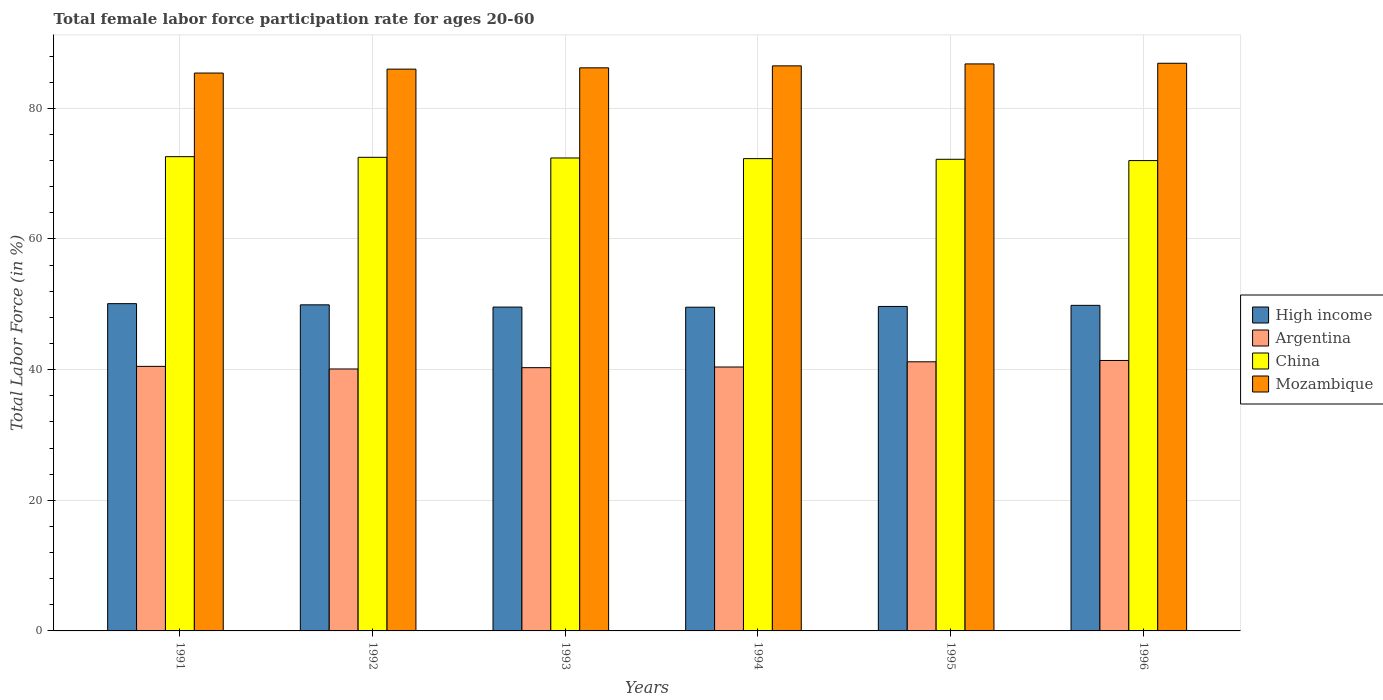How many different coloured bars are there?
Your response must be concise. 4. How many groups of bars are there?
Your answer should be compact. 6. Are the number of bars per tick equal to the number of legend labels?
Make the answer very short. Yes. How many bars are there on the 6th tick from the left?
Your answer should be compact. 4. How many bars are there on the 3rd tick from the right?
Your answer should be compact. 4. What is the female labor force participation rate in Argentina in 1996?
Offer a very short reply. 41.4. Across all years, what is the maximum female labor force participation rate in High income?
Give a very brief answer. 50.1. Across all years, what is the minimum female labor force participation rate in Mozambique?
Your answer should be very brief. 85.4. What is the total female labor force participation rate in China in the graph?
Provide a succinct answer. 434. What is the difference between the female labor force participation rate in Argentina in 1991 and that in 1994?
Provide a succinct answer. 0.1. What is the difference between the female labor force participation rate in Mozambique in 1991 and the female labor force participation rate in Argentina in 1994?
Your answer should be very brief. 45. What is the average female labor force participation rate in High income per year?
Your answer should be very brief. 49.78. In the year 1995, what is the difference between the female labor force participation rate in High income and female labor force participation rate in Argentina?
Give a very brief answer. 8.47. What is the ratio of the female labor force participation rate in High income in 1992 to that in 1993?
Keep it short and to the point. 1.01. Is the female labor force participation rate in High income in 1992 less than that in 1993?
Your response must be concise. No. What is the difference between the highest and the second highest female labor force participation rate in Mozambique?
Ensure brevity in your answer.  0.1. What is the difference between the highest and the lowest female labor force participation rate in High income?
Your answer should be compact. 0.54. What does the 4th bar from the left in 1991 represents?
Give a very brief answer. Mozambique. What does the 3rd bar from the right in 1993 represents?
Provide a succinct answer. Argentina. Is it the case that in every year, the sum of the female labor force participation rate in High income and female labor force participation rate in China is greater than the female labor force participation rate in Argentina?
Make the answer very short. Yes. How many years are there in the graph?
Give a very brief answer. 6. What is the difference between two consecutive major ticks on the Y-axis?
Provide a short and direct response. 20. Are the values on the major ticks of Y-axis written in scientific E-notation?
Keep it short and to the point. No. Does the graph contain any zero values?
Give a very brief answer. No. Does the graph contain grids?
Offer a very short reply. Yes. Where does the legend appear in the graph?
Provide a succinct answer. Center right. How many legend labels are there?
Make the answer very short. 4. How are the legend labels stacked?
Offer a terse response. Vertical. What is the title of the graph?
Offer a terse response. Total female labor force participation rate for ages 20-60. What is the label or title of the X-axis?
Your answer should be compact. Years. What is the Total Labor Force (in %) of High income in 1991?
Your response must be concise. 50.1. What is the Total Labor Force (in %) in Argentina in 1991?
Your answer should be compact. 40.5. What is the Total Labor Force (in %) in China in 1991?
Make the answer very short. 72.6. What is the Total Labor Force (in %) in Mozambique in 1991?
Keep it short and to the point. 85.4. What is the Total Labor Force (in %) in High income in 1992?
Your answer should be very brief. 49.92. What is the Total Labor Force (in %) of Argentina in 1992?
Provide a short and direct response. 40.1. What is the Total Labor Force (in %) in China in 1992?
Your answer should be compact. 72.5. What is the Total Labor Force (in %) in Mozambique in 1992?
Your answer should be very brief. 86. What is the Total Labor Force (in %) of High income in 1993?
Provide a short and direct response. 49.58. What is the Total Labor Force (in %) in Argentina in 1993?
Your answer should be very brief. 40.3. What is the Total Labor Force (in %) of China in 1993?
Provide a short and direct response. 72.4. What is the Total Labor Force (in %) of Mozambique in 1993?
Ensure brevity in your answer.  86.2. What is the Total Labor Force (in %) of High income in 1994?
Give a very brief answer. 49.56. What is the Total Labor Force (in %) of Argentina in 1994?
Keep it short and to the point. 40.4. What is the Total Labor Force (in %) of China in 1994?
Your answer should be compact. 72.3. What is the Total Labor Force (in %) in Mozambique in 1994?
Give a very brief answer. 86.5. What is the Total Labor Force (in %) in High income in 1995?
Your response must be concise. 49.67. What is the Total Labor Force (in %) in Argentina in 1995?
Keep it short and to the point. 41.2. What is the Total Labor Force (in %) in China in 1995?
Offer a terse response. 72.2. What is the Total Labor Force (in %) of Mozambique in 1995?
Make the answer very short. 86.8. What is the Total Labor Force (in %) of High income in 1996?
Ensure brevity in your answer.  49.84. What is the Total Labor Force (in %) of Argentina in 1996?
Keep it short and to the point. 41.4. What is the Total Labor Force (in %) in Mozambique in 1996?
Offer a terse response. 86.9. Across all years, what is the maximum Total Labor Force (in %) in High income?
Your answer should be very brief. 50.1. Across all years, what is the maximum Total Labor Force (in %) in Argentina?
Make the answer very short. 41.4. Across all years, what is the maximum Total Labor Force (in %) of China?
Ensure brevity in your answer.  72.6. Across all years, what is the maximum Total Labor Force (in %) in Mozambique?
Ensure brevity in your answer.  86.9. Across all years, what is the minimum Total Labor Force (in %) of High income?
Keep it short and to the point. 49.56. Across all years, what is the minimum Total Labor Force (in %) in Argentina?
Ensure brevity in your answer.  40.1. Across all years, what is the minimum Total Labor Force (in %) of Mozambique?
Provide a succinct answer. 85.4. What is the total Total Labor Force (in %) in High income in the graph?
Give a very brief answer. 298.66. What is the total Total Labor Force (in %) of Argentina in the graph?
Give a very brief answer. 243.9. What is the total Total Labor Force (in %) of China in the graph?
Offer a very short reply. 434. What is the total Total Labor Force (in %) of Mozambique in the graph?
Offer a terse response. 517.8. What is the difference between the Total Labor Force (in %) of High income in 1991 and that in 1992?
Give a very brief answer. 0.18. What is the difference between the Total Labor Force (in %) of China in 1991 and that in 1992?
Ensure brevity in your answer.  0.1. What is the difference between the Total Labor Force (in %) of Mozambique in 1991 and that in 1992?
Make the answer very short. -0.6. What is the difference between the Total Labor Force (in %) of High income in 1991 and that in 1993?
Your answer should be compact. 0.52. What is the difference between the Total Labor Force (in %) of Argentina in 1991 and that in 1993?
Ensure brevity in your answer.  0.2. What is the difference between the Total Labor Force (in %) of China in 1991 and that in 1993?
Your answer should be very brief. 0.2. What is the difference between the Total Labor Force (in %) of Mozambique in 1991 and that in 1993?
Give a very brief answer. -0.8. What is the difference between the Total Labor Force (in %) in High income in 1991 and that in 1994?
Ensure brevity in your answer.  0.54. What is the difference between the Total Labor Force (in %) in Argentina in 1991 and that in 1994?
Ensure brevity in your answer.  0.1. What is the difference between the Total Labor Force (in %) in China in 1991 and that in 1994?
Keep it short and to the point. 0.3. What is the difference between the Total Labor Force (in %) of High income in 1991 and that in 1995?
Provide a succinct answer. 0.43. What is the difference between the Total Labor Force (in %) in High income in 1991 and that in 1996?
Your answer should be very brief. 0.26. What is the difference between the Total Labor Force (in %) in Argentina in 1991 and that in 1996?
Your answer should be compact. -0.9. What is the difference between the Total Labor Force (in %) of Mozambique in 1991 and that in 1996?
Your response must be concise. -1.5. What is the difference between the Total Labor Force (in %) in High income in 1992 and that in 1993?
Offer a terse response. 0.34. What is the difference between the Total Labor Force (in %) in Mozambique in 1992 and that in 1993?
Ensure brevity in your answer.  -0.2. What is the difference between the Total Labor Force (in %) in High income in 1992 and that in 1994?
Your response must be concise. 0.36. What is the difference between the Total Labor Force (in %) of High income in 1992 and that in 1995?
Your answer should be compact. 0.25. What is the difference between the Total Labor Force (in %) of China in 1992 and that in 1995?
Offer a very short reply. 0.3. What is the difference between the Total Labor Force (in %) of Mozambique in 1992 and that in 1995?
Provide a short and direct response. -0.8. What is the difference between the Total Labor Force (in %) of High income in 1992 and that in 1996?
Ensure brevity in your answer.  0.08. What is the difference between the Total Labor Force (in %) in Mozambique in 1992 and that in 1996?
Offer a terse response. -0.9. What is the difference between the Total Labor Force (in %) of High income in 1993 and that in 1994?
Keep it short and to the point. 0.02. What is the difference between the Total Labor Force (in %) in Argentina in 1993 and that in 1994?
Keep it short and to the point. -0.1. What is the difference between the Total Labor Force (in %) in Mozambique in 1993 and that in 1994?
Offer a terse response. -0.3. What is the difference between the Total Labor Force (in %) of High income in 1993 and that in 1995?
Provide a short and direct response. -0.1. What is the difference between the Total Labor Force (in %) in Mozambique in 1993 and that in 1995?
Your answer should be compact. -0.6. What is the difference between the Total Labor Force (in %) of High income in 1993 and that in 1996?
Provide a succinct answer. -0.26. What is the difference between the Total Labor Force (in %) of Argentina in 1993 and that in 1996?
Offer a terse response. -1.1. What is the difference between the Total Labor Force (in %) of China in 1993 and that in 1996?
Keep it short and to the point. 0.4. What is the difference between the Total Labor Force (in %) in High income in 1994 and that in 1995?
Offer a very short reply. -0.12. What is the difference between the Total Labor Force (in %) of Argentina in 1994 and that in 1995?
Give a very brief answer. -0.8. What is the difference between the Total Labor Force (in %) in High income in 1994 and that in 1996?
Make the answer very short. -0.28. What is the difference between the Total Labor Force (in %) in China in 1994 and that in 1996?
Give a very brief answer. 0.3. What is the difference between the Total Labor Force (in %) of High income in 1995 and that in 1996?
Offer a terse response. -0.17. What is the difference between the Total Labor Force (in %) in Argentina in 1995 and that in 1996?
Offer a terse response. -0.2. What is the difference between the Total Labor Force (in %) of Mozambique in 1995 and that in 1996?
Your answer should be compact. -0.1. What is the difference between the Total Labor Force (in %) of High income in 1991 and the Total Labor Force (in %) of China in 1992?
Your answer should be very brief. -22.4. What is the difference between the Total Labor Force (in %) in High income in 1991 and the Total Labor Force (in %) in Mozambique in 1992?
Provide a short and direct response. -35.9. What is the difference between the Total Labor Force (in %) in Argentina in 1991 and the Total Labor Force (in %) in China in 1992?
Make the answer very short. -32. What is the difference between the Total Labor Force (in %) of Argentina in 1991 and the Total Labor Force (in %) of Mozambique in 1992?
Ensure brevity in your answer.  -45.5. What is the difference between the Total Labor Force (in %) in China in 1991 and the Total Labor Force (in %) in Mozambique in 1992?
Your response must be concise. -13.4. What is the difference between the Total Labor Force (in %) of High income in 1991 and the Total Labor Force (in %) of China in 1993?
Provide a short and direct response. -22.3. What is the difference between the Total Labor Force (in %) in High income in 1991 and the Total Labor Force (in %) in Mozambique in 1993?
Your answer should be very brief. -36.1. What is the difference between the Total Labor Force (in %) in Argentina in 1991 and the Total Labor Force (in %) in China in 1993?
Provide a succinct answer. -31.9. What is the difference between the Total Labor Force (in %) in Argentina in 1991 and the Total Labor Force (in %) in Mozambique in 1993?
Keep it short and to the point. -45.7. What is the difference between the Total Labor Force (in %) of High income in 1991 and the Total Labor Force (in %) of Argentina in 1994?
Your answer should be compact. 9.7. What is the difference between the Total Labor Force (in %) in High income in 1991 and the Total Labor Force (in %) in China in 1994?
Keep it short and to the point. -22.2. What is the difference between the Total Labor Force (in %) in High income in 1991 and the Total Labor Force (in %) in Mozambique in 1994?
Your answer should be very brief. -36.4. What is the difference between the Total Labor Force (in %) of Argentina in 1991 and the Total Labor Force (in %) of China in 1994?
Offer a terse response. -31.8. What is the difference between the Total Labor Force (in %) of Argentina in 1991 and the Total Labor Force (in %) of Mozambique in 1994?
Give a very brief answer. -46. What is the difference between the Total Labor Force (in %) in China in 1991 and the Total Labor Force (in %) in Mozambique in 1994?
Ensure brevity in your answer.  -13.9. What is the difference between the Total Labor Force (in %) in High income in 1991 and the Total Labor Force (in %) in China in 1995?
Offer a terse response. -22.1. What is the difference between the Total Labor Force (in %) of High income in 1991 and the Total Labor Force (in %) of Mozambique in 1995?
Ensure brevity in your answer.  -36.7. What is the difference between the Total Labor Force (in %) of Argentina in 1991 and the Total Labor Force (in %) of China in 1995?
Give a very brief answer. -31.7. What is the difference between the Total Labor Force (in %) in Argentina in 1991 and the Total Labor Force (in %) in Mozambique in 1995?
Ensure brevity in your answer.  -46.3. What is the difference between the Total Labor Force (in %) of China in 1991 and the Total Labor Force (in %) of Mozambique in 1995?
Ensure brevity in your answer.  -14.2. What is the difference between the Total Labor Force (in %) of High income in 1991 and the Total Labor Force (in %) of Argentina in 1996?
Keep it short and to the point. 8.7. What is the difference between the Total Labor Force (in %) in High income in 1991 and the Total Labor Force (in %) in China in 1996?
Your answer should be very brief. -21.9. What is the difference between the Total Labor Force (in %) in High income in 1991 and the Total Labor Force (in %) in Mozambique in 1996?
Provide a succinct answer. -36.8. What is the difference between the Total Labor Force (in %) of Argentina in 1991 and the Total Labor Force (in %) of China in 1996?
Provide a short and direct response. -31.5. What is the difference between the Total Labor Force (in %) in Argentina in 1991 and the Total Labor Force (in %) in Mozambique in 1996?
Make the answer very short. -46.4. What is the difference between the Total Labor Force (in %) of China in 1991 and the Total Labor Force (in %) of Mozambique in 1996?
Your response must be concise. -14.3. What is the difference between the Total Labor Force (in %) of High income in 1992 and the Total Labor Force (in %) of Argentina in 1993?
Provide a succinct answer. 9.62. What is the difference between the Total Labor Force (in %) in High income in 1992 and the Total Labor Force (in %) in China in 1993?
Provide a short and direct response. -22.48. What is the difference between the Total Labor Force (in %) in High income in 1992 and the Total Labor Force (in %) in Mozambique in 1993?
Provide a short and direct response. -36.28. What is the difference between the Total Labor Force (in %) of Argentina in 1992 and the Total Labor Force (in %) of China in 1993?
Your response must be concise. -32.3. What is the difference between the Total Labor Force (in %) of Argentina in 1992 and the Total Labor Force (in %) of Mozambique in 1993?
Provide a short and direct response. -46.1. What is the difference between the Total Labor Force (in %) in China in 1992 and the Total Labor Force (in %) in Mozambique in 1993?
Your answer should be compact. -13.7. What is the difference between the Total Labor Force (in %) in High income in 1992 and the Total Labor Force (in %) in Argentina in 1994?
Keep it short and to the point. 9.52. What is the difference between the Total Labor Force (in %) of High income in 1992 and the Total Labor Force (in %) of China in 1994?
Provide a short and direct response. -22.38. What is the difference between the Total Labor Force (in %) in High income in 1992 and the Total Labor Force (in %) in Mozambique in 1994?
Keep it short and to the point. -36.58. What is the difference between the Total Labor Force (in %) of Argentina in 1992 and the Total Labor Force (in %) of China in 1994?
Keep it short and to the point. -32.2. What is the difference between the Total Labor Force (in %) of Argentina in 1992 and the Total Labor Force (in %) of Mozambique in 1994?
Offer a very short reply. -46.4. What is the difference between the Total Labor Force (in %) of China in 1992 and the Total Labor Force (in %) of Mozambique in 1994?
Give a very brief answer. -14. What is the difference between the Total Labor Force (in %) in High income in 1992 and the Total Labor Force (in %) in Argentina in 1995?
Offer a very short reply. 8.72. What is the difference between the Total Labor Force (in %) in High income in 1992 and the Total Labor Force (in %) in China in 1995?
Your response must be concise. -22.28. What is the difference between the Total Labor Force (in %) of High income in 1992 and the Total Labor Force (in %) of Mozambique in 1995?
Your answer should be very brief. -36.88. What is the difference between the Total Labor Force (in %) in Argentina in 1992 and the Total Labor Force (in %) in China in 1995?
Your answer should be compact. -32.1. What is the difference between the Total Labor Force (in %) in Argentina in 1992 and the Total Labor Force (in %) in Mozambique in 1995?
Offer a terse response. -46.7. What is the difference between the Total Labor Force (in %) in China in 1992 and the Total Labor Force (in %) in Mozambique in 1995?
Provide a short and direct response. -14.3. What is the difference between the Total Labor Force (in %) of High income in 1992 and the Total Labor Force (in %) of Argentina in 1996?
Your response must be concise. 8.52. What is the difference between the Total Labor Force (in %) of High income in 1992 and the Total Labor Force (in %) of China in 1996?
Ensure brevity in your answer.  -22.08. What is the difference between the Total Labor Force (in %) in High income in 1992 and the Total Labor Force (in %) in Mozambique in 1996?
Make the answer very short. -36.98. What is the difference between the Total Labor Force (in %) in Argentina in 1992 and the Total Labor Force (in %) in China in 1996?
Your answer should be compact. -31.9. What is the difference between the Total Labor Force (in %) of Argentina in 1992 and the Total Labor Force (in %) of Mozambique in 1996?
Your response must be concise. -46.8. What is the difference between the Total Labor Force (in %) of China in 1992 and the Total Labor Force (in %) of Mozambique in 1996?
Your response must be concise. -14.4. What is the difference between the Total Labor Force (in %) of High income in 1993 and the Total Labor Force (in %) of Argentina in 1994?
Make the answer very short. 9.18. What is the difference between the Total Labor Force (in %) of High income in 1993 and the Total Labor Force (in %) of China in 1994?
Ensure brevity in your answer.  -22.72. What is the difference between the Total Labor Force (in %) of High income in 1993 and the Total Labor Force (in %) of Mozambique in 1994?
Your answer should be compact. -36.92. What is the difference between the Total Labor Force (in %) of Argentina in 1993 and the Total Labor Force (in %) of China in 1994?
Ensure brevity in your answer.  -32. What is the difference between the Total Labor Force (in %) of Argentina in 1993 and the Total Labor Force (in %) of Mozambique in 1994?
Keep it short and to the point. -46.2. What is the difference between the Total Labor Force (in %) in China in 1993 and the Total Labor Force (in %) in Mozambique in 1994?
Your answer should be compact. -14.1. What is the difference between the Total Labor Force (in %) of High income in 1993 and the Total Labor Force (in %) of Argentina in 1995?
Provide a short and direct response. 8.38. What is the difference between the Total Labor Force (in %) of High income in 1993 and the Total Labor Force (in %) of China in 1995?
Ensure brevity in your answer.  -22.62. What is the difference between the Total Labor Force (in %) of High income in 1993 and the Total Labor Force (in %) of Mozambique in 1995?
Offer a very short reply. -37.22. What is the difference between the Total Labor Force (in %) in Argentina in 1993 and the Total Labor Force (in %) in China in 1995?
Offer a very short reply. -31.9. What is the difference between the Total Labor Force (in %) in Argentina in 1993 and the Total Labor Force (in %) in Mozambique in 1995?
Provide a succinct answer. -46.5. What is the difference between the Total Labor Force (in %) of China in 1993 and the Total Labor Force (in %) of Mozambique in 1995?
Your answer should be very brief. -14.4. What is the difference between the Total Labor Force (in %) of High income in 1993 and the Total Labor Force (in %) of Argentina in 1996?
Keep it short and to the point. 8.18. What is the difference between the Total Labor Force (in %) of High income in 1993 and the Total Labor Force (in %) of China in 1996?
Offer a terse response. -22.42. What is the difference between the Total Labor Force (in %) of High income in 1993 and the Total Labor Force (in %) of Mozambique in 1996?
Offer a very short reply. -37.32. What is the difference between the Total Labor Force (in %) of Argentina in 1993 and the Total Labor Force (in %) of China in 1996?
Your answer should be very brief. -31.7. What is the difference between the Total Labor Force (in %) of Argentina in 1993 and the Total Labor Force (in %) of Mozambique in 1996?
Provide a succinct answer. -46.6. What is the difference between the Total Labor Force (in %) of High income in 1994 and the Total Labor Force (in %) of Argentina in 1995?
Keep it short and to the point. 8.36. What is the difference between the Total Labor Force (in %) of High income in 1994 and the Total Labor Force (in %) of China in 1995?
Give a very brief answer. -22.64. What is the difference between the Total Labor Force (in %) of High income in 1994 and the Total Labor Force (in %) of Mozambique in 1995?
Your answer should be compact. -37.24. What is the difference between the Total Labor Force (in %) of Argentina in 1994 and the Total Labor Force (in %) of China in 1995?
Offer a very short reply. -31.8. What is the difference between the Total Labor Force (in %) of Argentina in 1994 and the Total Labor Force (in %) of Mozambique in 1995?
Keep it short and to the point. -46.4. What is the difference between the Total Labor Force (in %) of China in 1994 and the Total Labor Force (in %) of Mozambique in 1995?
Make the answer very short. -14.5. What is the difference between the Total Labor Force (in %) of High income in 1994 and the Total Labor Force (in %) of Argentina in 1996?
Give a very brief answer. 8.16. What is the difference between the Total Labor Force (in %) in High income in 1994 and the Total Labor Force (in %) in China in 1996?
Your answer should be very brief. -22.44. What is the difference between the Total Labor Force (in %) of High income in 1994 and the Total Labor Force (in %) of Mozambique in 1996?
Make the answer very short. -37.34. What is the difference between the Total Labor Force (in %) in Argentina in 1994 and the Total Labor Force (in %) in China in 1996?
Your answer should be very brief. -31.6. What is the difference between the Total Labor Force (in %) in Argentina in 1994 and the Total Labor Force (in %) in Mozambique in 1996?
Your response must be concise. -46.5. What is the difference between the Total Labor Force (in %) of China in 1994 and the Total Labor Force (in %) of Mozambique in 1996?
Provide a succinct answer. -14.6. What is the difference between the Total Labor Force (in %) of High income in 1995 and the Total Labor Force (in %) of Argentina in 1996?
Keep it short and to the point. 8.27. What is the difference between the Total Labor Force (in %) of High income in 1995 and the Total Labor Force (in %) of China in 1996?
Offer a very short reply. -22.33. What is the difference between the Total Labor Force (in %) in High income in 1995 and the Total Labor Force (in %) in Mozambique in 1996?
Provide a succinct answer. -37.23. What is the difference between the Total Labor Force (in %) of Argentina in 1995 and the Total Labor Force (in %) of China in 1996?
Offer a very short reply. -30.8. What is the difference between the Total Labor Force (in %) of Argentina in 1995 and the Total Labor Force (in %) of Mozambique in 1996?
Give a very brief answer. -45.7. What is the difference between the Total Labor Force (in %) in China in 1995 and the Total Labor Force (in %) in Mozambique in 1996?
Offer a terse response. -14.7. What is the average Total Labor Force (in %) in High income per year?
Your response must be concise. 49.78. What is the average Total Labor Force (in %) in Argentina per year?
Provide a succinct answer. 40.65. What is the average Total Labor Force (in %) in China per year?
Provide a succinct answer. 72.33. What is the average Total Labor Force (in %) in Mozambique per year?
Ensure brevity in your answer.  86.3. In the year 1991, what is the difference between the Total Labor Force (in %) in High income and Total Labor Force (in %) in China?
Your answer should be very brief. -22.5. In the year 1991, what is the difference between the Total Labor Force (in %) in High income and Total Labor Force (in %) in Mozambique?
Your answer should be very brief. -35.3. In the year 1991, what is the difference between the Total Labor Force (in %) of Argentina and Total Labor Force (in %) of China?
Provide a short and direct response. -32.1. In the year 1991, what is the difference between the Total Labor Force (in %) of Argentina and Total Labor Force (in %) of Mozambique?
Offer a terse response. -44.9. In the year 1992, what is the difference between the Total Labor Force (in %) in High income and Total Labor Force (in %) in Argentina?
Provide a short and direct response. 9.82. In the year 1992, what is the difference between the Total Labor Force (in %) in High income and Total Labor Force (in %) in China?
Your answer should be compact. -22.58. In the year 1992, what is the difference between the Total Labor Force (in %) of High income and Total Labor Force (in %) of Mozambique?
Offer a very short reply. -36.08. In the year 1992, what is the difference between the Total Labor Force (in %) in Argentina and Total Labor Force (in %) in China?
Keep it short and to the point. -32.4. In the year 1992, what is the difference between the Total Labor Force (in %) in Argentina and Total Labor Force (in %) in Mozambique?
Your answer should be compact. -45.9. In the year 1993, what is the difference between the Total Labor Force (in %) of High income and Total Labor Force (in %) of Argentina?
Your answer should be compact. 9.28. In the year 1993, what is the difference between the Total Labor Force (in %) in High income and Total Labor Force (in %) in China?
Your answer should be compact. -22.82. In the year 1993, what is the difference between the Total Labor Force (in %) of High income and Total Labor Force (in %) of Mozambique?
Your answer should be very brief. -36.62. In the year 1993, what is the difference between the Total Labor Force (in %) of Argentina and Total Labor Force (in %) of China?
Give a very brief answer. -32.1. In the year 1993, what is the difference between the Total Labor Force (in %) in Argentina and Total Labor Force (in %) in Mozambique?
Provide a succinct answer. -45.9. In the year 1993, what is the difference between the Total Labor Force (in %) in China and Total Labor Force (in %) in Mozambique?
Offer a very short reply. -13.8. In the year 1994, what is the difference between the Total Labor Force (in %) of High income and Total Labor Force (in %) of Argentina?
Your answer should be compact. 9.16. In the year 1994, what is the difference between the Total Labor Force (in %) in High income and Total Labor Force (in %) in China?
Make the answer very short. -22.74. In the year 1994, what is the difference between the Total Labor Force (in %) of High income and Total Labor Force (in %) of Mozambique?
Ensure brevity in your answer.  -36.94. In the year 1994, what is the difference between the Total Labor Force (in %) of Argentina and Total Labor Force (in %) of China?
Offer a terse response. -31.9. In the year 1994, what is the difference between the Total Labor Force (in %) of Argentina and Total Labor Force (in %) of Mozambique?
Your answer should be compact. -46.1. In the year 1995, what is the difference between the Total Labor Force (in %) in High income and Total Labor Force (in %) in Argentina?
Provide a short and direct response. 8.47. In the year 1995, what is the difference between the Total Labor Force (in %) in High income and Total Labor Force (in %) in China?
Provide a succinct answer. -22.53. In the year 1995, what is the difference between the Total Labor Force (in %) in High income and Total Labor Force (in %) in Mozambique?
Provide a succinct answer. -37.13. In the year 1995, what is the difference between the Total Labor Force (in %) in Argentina and Total Labor Force (in %) in China?
Give a very brief answer. -31. In the year 1995, what is the difference between the Total Labor Force (in %) in Argentina and Total Labor Force (in %) in Mozambique?
Keep it short and to the point. -45.6. In the year 1995, what is the difference between the Total Labor Force (in %) of China and Total Labor Force (in %) of Mozambique?
Your response must be concise. -14.6. In the year 1996, what is the difference between the Total Labor Force (in %) of High income and Total Labor Force (in %) of Argentina?
Provide a succinct answer. 8.44. In the year 1996, what is the difference between the Total Labor Force (in %) of High income and Total Labor Force (in %) of China?
Keep it short and to the point. -22.16. In the year 1996, what is the difference between the Total Labor Force (in %) of High income and Total Labor Force (in %) of Mozambique?
Give a very brief answer. -37.06. In the year 1996, what is the difference between the Total Labor Force (in %) in Argentina and Total Labor Force (in %) in China?
Your answer should be very brief. -30.6. In the year 1996, what is the difference between the Total Labor Force (in %) of Argentina and Total Labor Force (in %) of Mozambique?
Your answer should be very brief. -45.5. In the year 1996, what is the difference between the Total Labor Force (in %) of China and Total Labor Force (in %) of Mozambique?
Your response must be concise. -14.9. What is the ratio of the Total Labor Force (in %) of Argentina in 1991 to that in 1992?
Your answer should be compact. 1.01. What is the ratio of the Total Labor Force (in %) in China in 1991 to that in 1992?
Offer a terse response. 1. What is the ratio of the Total Labor Force (in %) of High income in 1991 to that in 1993?
Your answer should be compact. 1.01. What is the ratio of the Total Labor Force (in %) of Argentina in 1991 to that in 1993?
Make the answer very short. 1. What is the ratio of the Total Labor Force (in %) of China in 1991 to that in 1993?
Ensure brevity in your answer.  1. What is the ratio of the Total Labor Force (in %) in High income in 1991 to that in 1994?
Give a very brief answer. 1.01. What is the ratio of the Total Labor Force (in %) of Argentina in 1991 to that in 1994?
Your answer should be compact. 1. What is the ratio of the Total Labor Force (in %) of Mozambique in 1991 to that in 1994?
Offer a terse response. 0.99. What is the ratio of the Total Labor Force (in %) of High income in 1991 to that in 1995?
Make the answer very short. 1.01. What is the ratio of the Total Labor Force (in %) of Mozambique in 1991 to that in 1995?
Keep it short and to the point. 0.98. What is the ratio of the Total Labor Force (in %) in High income in 1991 to that in 1996?
Keep it short and to the point. 1.01. What is the ratio of the Total Labor Force (in %) of Argentina in 1991 to that in 1996?
Your response must be concise. 0.98. What is the ratio of the Total Labor Force (in %) in China in 1991 to that in 1996?
Provide a short and direct response. 1.01. What is the ratio of the Total Labor Force (in %) in Mozambique in 1991 to that in 1996?
Your answer should be compact. 0.98. What is the ratio of the Total Labor Force (in %) in High income in 1992 to that in 1993?
Your response must be concise. 1.01. What is the ratio of the Total Labor Force (in %) in China in 1992 to that in 1993?
Provide a short and direct response. 1. What is the ratio of the Total Labor Force (in %) in Mozambique in 1992 to that in 1993?
Provide a succinct answer. 1. What is the ratio of the Total Labor Force (in %) of High income in 1992 to that in 1994?
Your response must be concise. 1.01. What is the ratio of the Total Labor Force (in %) of Argentina in 1992 to that in 1994?
Your answer should be compact. 0.99. What is the ratio of the Total Labor Force (in %) of China in 1992 to that in 1994?
Your answer should be compact. 1. What is the ratio of the Total Labor Force (in %) in Argentina in 1992 to that in 1995?
Your answer should be compact. 0.97. What is the ratio of the Total Labor Force (in %) of China in 1992 to that in 1995?
Provide a succinct answer. 1. What is the ratio of the Total Labor Force (in %) in Argentina in 1992 to that in 1996?
Your response must be concise. 0.97. What is the ratio of the Total Labor Force (in %) in Mozambique in 1992 to that in 1996?
Provide a succinct answer. 0.99. What is the ratio of the Total Labor Force (in %) of High income in 1993 to that in 1994?
Keep it short and to the point. 1. What is the ratio of the Total Labor Force (in %) in Argentina in 1993 to that in 1994?
Offer a terse response. 1. What is the ratio of the Total Labor Force (in %) of Mozambique in 1993 to that in 1994?
Provide a succinct answer. 1. What is the ratio of the Total Labor Force (in %) of Argentina in 1993 to that in 1995?
Keep it short and to the point. 0.98. What is the ratio of the Total Labor Force (in %) of China in 1993 to that in 1995?
Offer a terse response. 1. What is the ratio of the Total Labor Force (in %) of Argentina in 1993 to that in 1996?
Keep it short and to the point. 0.97. What is the ratio of the Total Labor Force (in %) in China in 1993 to that in 1996?
Your answer should be very brief. 1.01. What is the ratio of the Total Labor Force (in %) in Mozambique in 1993 to that in 1996?
Offer a very short reply. 0.99. What is the ratio of the Total Labor Force (in %) in Argentina in 1994 to that in 1995?
Provide a short and direct response. 0.98. What is the ratio of the Total Labor Force (in %) in Mozambique in 1994 to that in 1995?
Keep it short and to the point. 1. What is the ratio of the Total Labor Force (in %) of Argentina in 1994 to that in 1996?
Your response must be concise. 0.98. What is the ratio of the Total Labor Force (in %) of China in 1994 to that in 1996?
Provide a short and direct response. 1. What is the ratio of the Total Labor Force (in %) in Mozambique in 1994 to that in 1996?
Offer a very short reply. 1. What is the ratio of the Total Labor Force (in %) in Argentina in 1995 to that in 1996?
Your answer should be very brief. 1. What is the ratio of the Total Labor Force (in %) of Mozambique in 1995 to that in 1996?
Make the answer very short. 1. What is the difference between the highest and the second highest Total Labor Force (in %) of High income?
Your response must be concise. 0.18. What is the difference between the highest and the second highest Total Labor Force (in %) of Mozambique?
Make the answer very short. 0.1. What is the difference between the highest and the lowest Total Labor Force (in %) in High income?
Your answer should be compact. 0.54. What is the difference between the highest and the lowest Total Labor Force (in %) in Mozambique?
Provide a succinct answer. 1.5. 